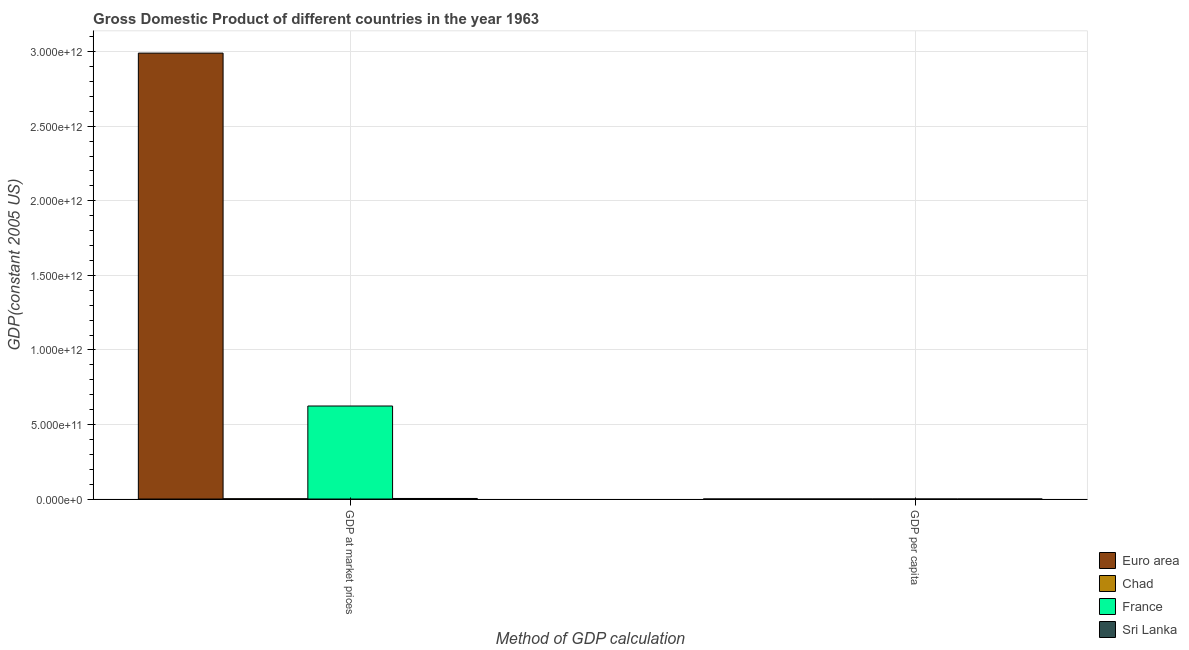How many different coloured bars are there?
Give a very brief answer. 4. Are the number of bars per tick equal to the number of legend labels?
Provide a succinct answer. Yes. Are the number of bars on each tick of the X-axis equal?
Give a very brief answer. Yes. What is the label of the 1st group of bars from the left?
Give a very brief answer. GDP at market prices. What is the gdp per capita in Euro area?
Your answer should be compact. 1.10e+04. Across all countries, what is the maximum gdp per capita?
Give a very brief answer. 1.28e+04. Across all countries, what is the minimum gdp at market prices?
Make the answer very short. 1.74e+09. In which country was the gdp per capita maximum?
Ensure brevity in your answer.  France. In which country was the gdp per capita minimum?
Provide a short and direct response. Sri Lanka. What is the total gdp per capita in the graph?
Your answer should be very brief. 2.46e+04. What is the difference between the gdp per capita in Euro area and that in Sri Lanka?
Your response must be concise. 1.06e+04. What is the difference between the gdp at market prices in Euro area and the gdp per capita in France?
Provide a succinct answer. 2.99e+12. What is the average gdp per capita per country?
Your answer should be compact. 6159.05. What is the difference between the gdp per capita and gdp at market prices in Sri Lanka?
Give a very brief answer. -3.70e+09. In how many countries, is the gdp at market prices greater than 700000000000 US$?
Your answer should be compact. 1. What is the ratio of the gdp at market prices in France to that in Sri Lanka?
Offer a very short reply. 168.77. Is the gdp at market prices in Euro area less than that in Sri Lanka?
Make the answer very short. No. What does the 3rd bar from the right in GDP at market prices represents?
Give a very brief answer. Chad. How many bars are there?
Keep it short and to the point. 8. What is the difference between two consecutive major ticks on the Y-axis?
Ensure brevity in your answer.  5.00e+11. Does the graph contain grids?
Your answer should be compact. Yes. Where does the legend appear in the graph?
Your answer should be very brief. Bottom right. How many legend labels are there?
Give a very brief answer. 4. How are the legend labels stacked?
Give a very brief answer. Vertical. What is the title of the graph?
Your response must be concise. Gross Domestic Product of different countries in the year 1963. What is the label or title of the X-axis?
Provide a succinct answer. Method of GDP calculation. What is the label or title of the Y-axis?
Ensure brevity in your answer.  GDP(constant 2005 US). What is the GDP(constant 2005 US) in Euro area in GDP at market prices?
Ensure brevity in your answer.  2.99e+12. What is the GDP(constant 2005 US) of Chad in GDP at market prices?
Make the answer very short. 1.74e+09. What is the GDP(constant 2005 US) of France in GDP at market prices?
Your answer should be very brief. 6.24e+11. What is the GDP(constant 2005 US) in Sri Lanka in GDP at market prices?
Provide a short and direct response. 3.70e+09. What is the GDP(constant 2005 US) of Euro area in GDP per capita?
Offer a very short reply. 1.10e+04. What is the GDP(constant 2005 US) of Chad in GDP per capita?
Offer a terse response. 545.35. What is the GDP(constant 2005 US) of France in GDP per capita?
Offer a very short reply. 1.28e+04. What is the GDP(constant 2005 US) in Sri Lanka in GDP per capita?
Your answer should be compact. 349.31. Across all Method of GDP calculation, what is the maximum GDP(constant 2005 US) in Euro area?
Your answer should be compact. 2.99e+12. Across all Method of GDP calculation, what is the maximum GDP(constant 2005 US) in Chad?
Your answer should be compact. 1.74e+09. Across all Method of GDP calculation, what is the maximum GDP(constant 2005 US) of France?
Offer a very short reply. 6.24e+11. Across all Method of GDP calculation, what is the maximum GDP(constant 2005 US) in Sri Lanka?
Provide a succinct answer. 3.70e+09. Across all Method of GDP calculation, what is the minimum GDP(constant 2005 US) in Euro area?
Keep it short and to the point. 1.10e+04. Across all Method of GDP calculation, what is the minimum GDP(constant 2005 US) of Chad?
Provide a short and direct response. 545.35. Across all Method of GDP calculation, what is the minimum GDP(constant 2005 US) of France?
Offer a terse response. 1.28e+04. Across all Method of GDP calculation, what is the minimum GDP(constant 2005 US) in Sri Lanka?
Provide a succinct answer. 349.31. What is the total GDP(constant 2005 US) of Euro area in the graph?
Ensure brevity in your answer.  2.99e+12. What is the total GDP(constant 2005 US) of Chad in the graph?
Ensure brevity in your answer.  1.74e+09. What is the total GDP(constant 2005 US) of France in the graph?
Make the answer very short. 6.24e+11. What is the total GDP(constant 2005 US) of Sri Lanka in the graph?
Give a very brief answer. 3.70e+09. What is the difference between the GDP(constant 2005 US) of Euro area in GDP at market prices and that in GDP per capita?
Offer a terse response. 2.99e+12. What is the difference between the GDP(constant 2005 US) in Chad in GDP at market prices and that in GDP per capita?
Ensure brevity in your answer.  1.74e+09. What is the difference between the GDP(constant 2005 US) in France in GDP at market prices and that in GDP per capita?
Provide a short and direct response. 6.24e+11. What is the difference between the GDP(constant 2005 US) of Sri Lanka in GDP at market prices and that in GDP per capita?
Your answer should be very brief. 3.70e+09. What is the difference between the GDP(constant 2005 US) in Euro area in GDP at market prices and the GDP(constant 2005 US) in Chad in GDP per capita?
Offer a very short reply. 2.99e+12. What is the difference between the GDP(constant 2005 US) in Euro area in GDP at market prices and the GDP(constant 2005 US) in France in GDP per capita?
Your answer should be very brief. 2.99e+12. What is the difference between the GDP(constant 2005 US) in Euro area in GDP at market prices and the GDP(constant 2005 US) in Sri Lanka in GDP per capita?
Your response must be concise. 2.99e+12. What is the difference between the GDP(constant 2005 US) in Chad in GDP at market prices and the GDP(constant 2005 US) in France in GDP per capita?
Ensure brevity in your answer.  1.74e+09. What is the difference between the GDP(constant 2005 US) in Chad in GDP at market prices and the GDP(constant 2005 US) in Sri Lanka in GDP per capita?
Your answer should be very brief. 1.74e+09. What is the difference between the GDP(constant 2005 US) of France in GDP at market prices and the GDP(constant 2005 US) of Sri Lanka in GDP per capita?
Provide a succinct answer. 6.24e+11. What is the average GDP(constant 2005 US) in Euro area per Method of GDP calculation?
Offer a terse response. 1.50e+12. What is the average GDP(constant 2005 US) in Chad per Method of GDP calculation?
Offer a very short reply. 8.68e+08. What is the average GDP(constant 2005 US) in France per Method of GDP calculation?
Your answer should be compact. 3.12e+11. What is the average GDP(constant 2005 US) of Sri Lanka per Method of GDP calculation?
Your answer should be very brief. 1.85e+09. What is the difference between the GDP(constant 2005 US) in Euro area and GDP(constant 2005 US) in Chad in GDP at market prices?
Keep it short and to the point. 2.99e+12. What is the difference between the GDP(constant 2005 US) in Euro area and GDP(constant 2005 US) in France in GDP at market prices?
Keep it short and to the point. 2.37e+12. What is the difference between the GDP(constant 2005 US) in Euro area and GDP(constant 2005 US) in Sri Lanka in GDP at market prices?
Offer a terse response. 2.99e+12. What is the difference between the GDP(constant 2005 US) in Chad and GDP(constant 2005 US) in France in GDP at market prices?
Your answer should be compact. -6.22e+11. What is the difference between the GDP(constant 2005 US) in Chad and GDP(constant 2005 US) in Sri Lanka in GDP at market prices?
Keep it short and to the point. -1.96e+09. What is the difference between the GDP(constant 2005 US) in France and GDP(constant 2005 US) in Sri Lanka in GDP at market prices?
Ensure brevity in your answer.  6.20e+11. What is the difference between the GDP(constant 2005 US) of Euro area and GDP(constant 2005 US) of Chad in GDP per capita?
Provide a succinct answer. 1.04e+04. What is the difference between the GDP(constant 2005 US) of Euro area and GDP(constant 2005 US) of France in GDP per capita?
Offer a terse response. -1823.48. What is the difference between the GDP(constant 2005 US) of Euro area and GDP(constant 2005 US) of Sri Lanka in GDP per capita?
Your answer should be very brief. 1.06e+04. What is the difference between the GDP(constant 2005 US) of Chad and GDP(constant 2005 US) of France in GDP per capita?
Ensure brevity in your answer.  -1.22e+04. What is the difference between the GDP(constant 2005 US) in Chad and GDP(constant 2005 US) in Sri Lanka in GDP per capita?
Offer a very short reply. 196.04. What is the difference between the GDP(constant 2005 US) of France and GDP(constant 2005 US) of Sri Lanka in GDP per capita?
Your response must be concise. 1.24e+04. What is the ratio of the GDP(constant 2005 US) in Euro area in GDP at market prices to that in GDP per capita?
Give a very brief answer. 2.73e+08. What is the ratio of the GDP(constant 2005 US) of Chad in GDP at market prices to that in GDP per capita?
Your answer should be very brief. 3.18e+06. What is the ratio of the GDP(constant 2005 US) in France in GDP at market prices to that in GDP per capita?
Ensure brevity in your answer.  4.88e+07. What is the ratio of the GDP(constant 2005 US) of Sri Lanka in GDP at market prices to that in GDP per capita?
Provide a short and direct response. 1.06e+07. What is the difference between the highest and the second highest GDP(constant 2005 US) in Euro area?
Ensure brevity in your answer.  2.99e+12. What is the difference between the highest and the second highest GDP(constant 2005 US) in Chad?
Offer a very short reply. 1.74e+09. What is the difference between the highest and the second highest GDP(constant 2005 US) in France?
Your answer should be very brief. 6.24e+11. What is the difference between the highest and the second highest GDP(constant 2005 US) in Sri Lanka?
Offer a very short reply. 3.70e+09. What is the difference between the highest and the lowest GDP(constant 2005 US) in Euro area?
Keep it short and to the point. 2.99e+12. What is the difference between the highest and the lowest GDP(constant 2005 US) in Chad?
Your response must be concise. 1.74e+09. What is the difference between the highest and the lowest GDP(constant 2005 US) of France?
Your response must be concise. 6.24e+11. What is the difference between the highest and the lowest GDP(constant 2005 US) of Sri Lanka?
Give a very brief answer. 3.70e+09. 